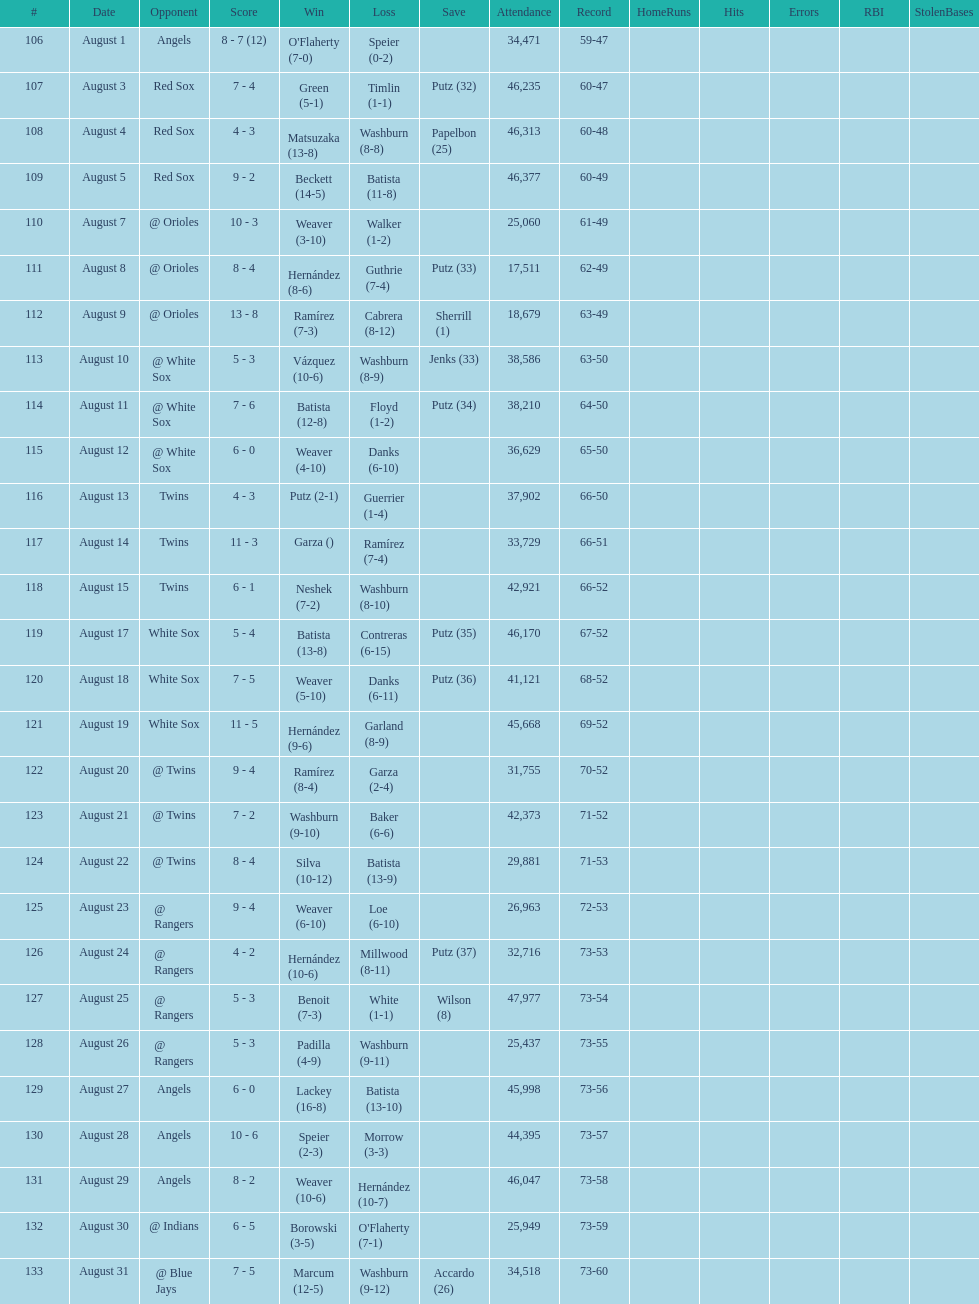What was the total number of games played in august 2007? 28. 